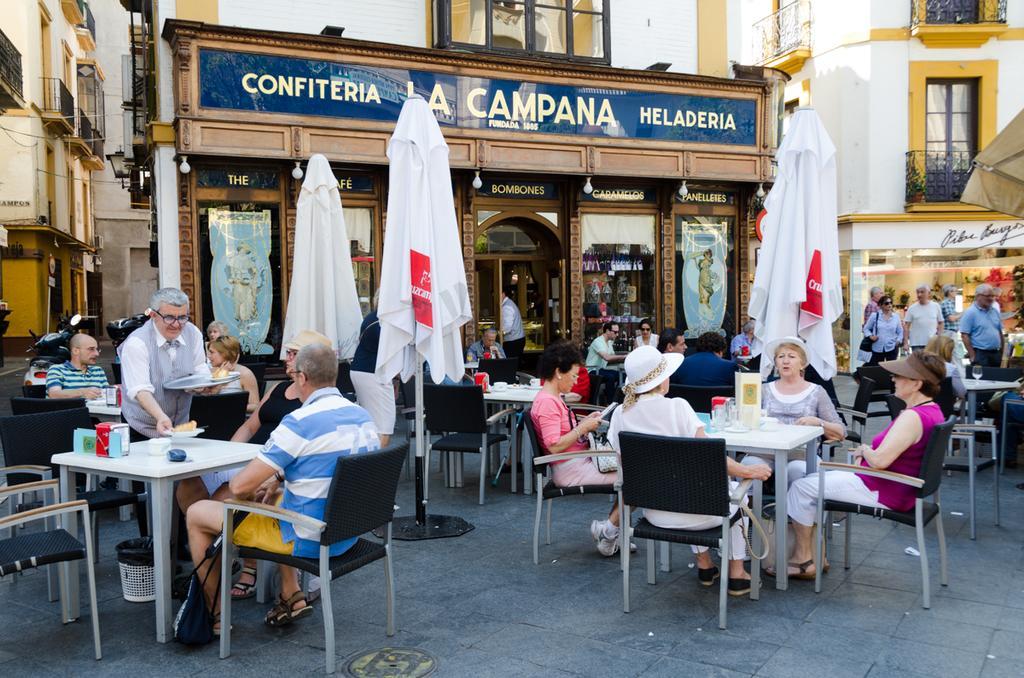Could you give a brief overview of what you see in this image? In this image I can see number of people were few are standing and rest all are sitting on chairs. I can also see few tables and few buildings. Here I can see few vehicles. 